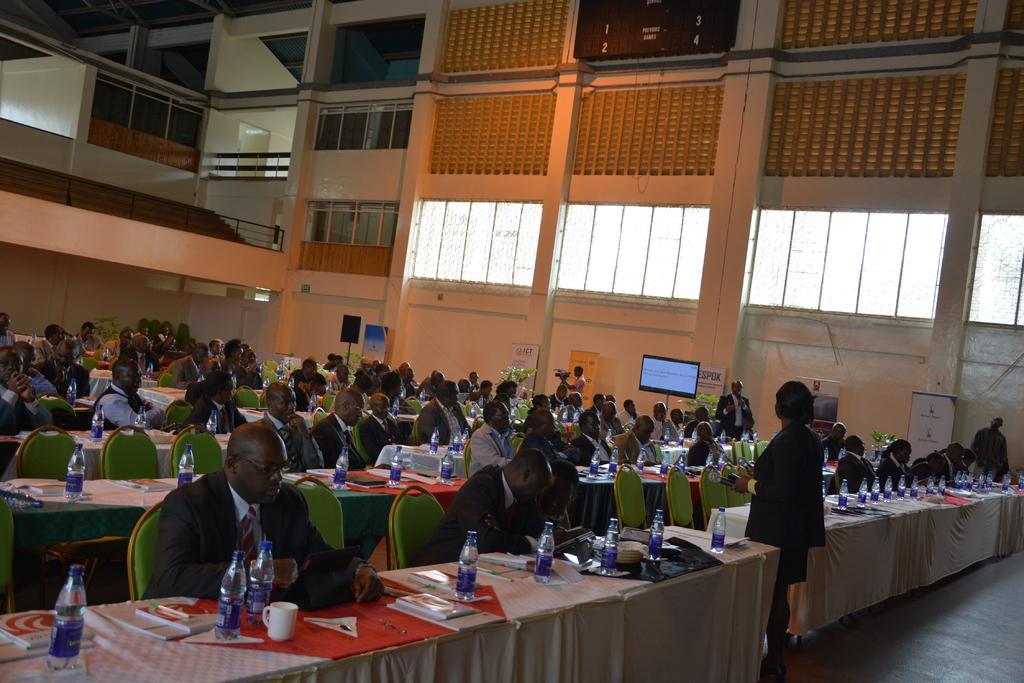Can you describe this image briefly? In this picture we can see a group of people sitting on chairs and in front of them on table we have bottles, cups, books and in front one person is standing and in background we can see wall, windows, speakers, banners, person holding camera, screen. 